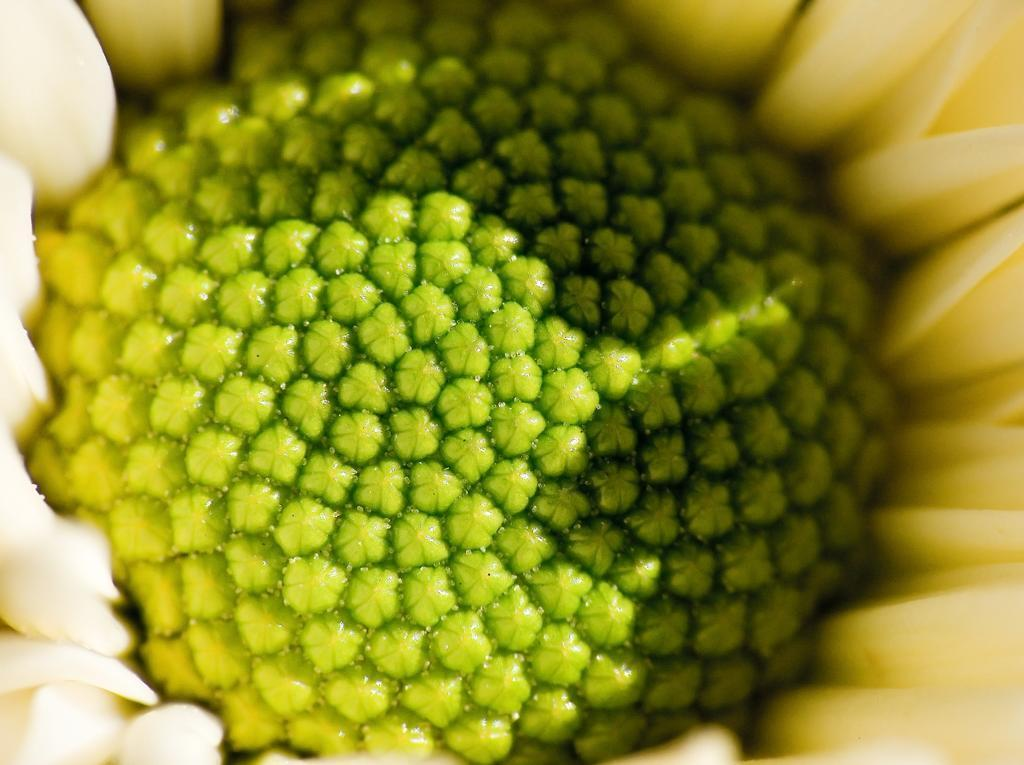What is the main subject of the image? There is a flower in the image. What type of cracker is being blown by the wind on the floor in the image? There is no cracker, wind, or floor present in the image; it only features a flower. 